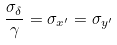Convert formula to latex. <formula><loc_0><loc_0><loc_500><loc_500>\frac { \sigma _ { \delta } } { \gamma } = \sigma _ { x ^ { \prime } } = \sigma _ { y ^ { \prime } }</formula> 